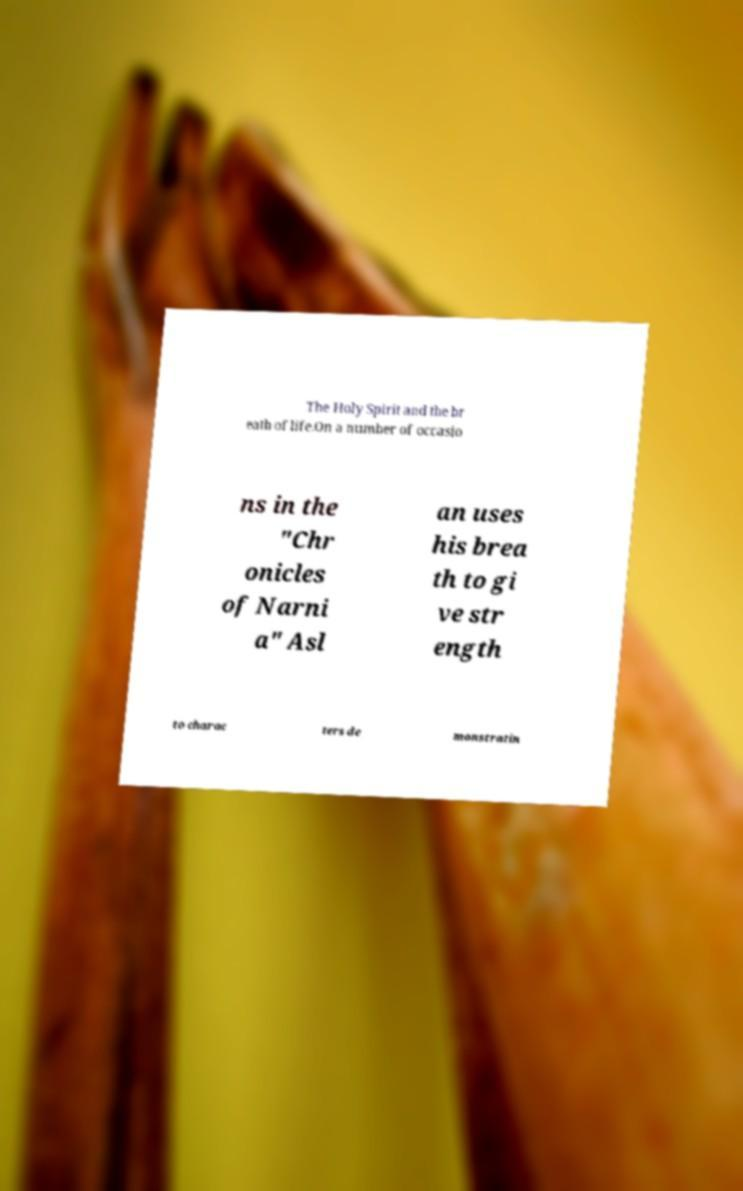Can you accurately transcribe the text from the provided image for me? The Holy Spirit and the br eath of life.On a number of occasio ns in the "Chr onicles of Narni a" Asl an uses his brea th to gi ve str ength to charac ters de monstratin 